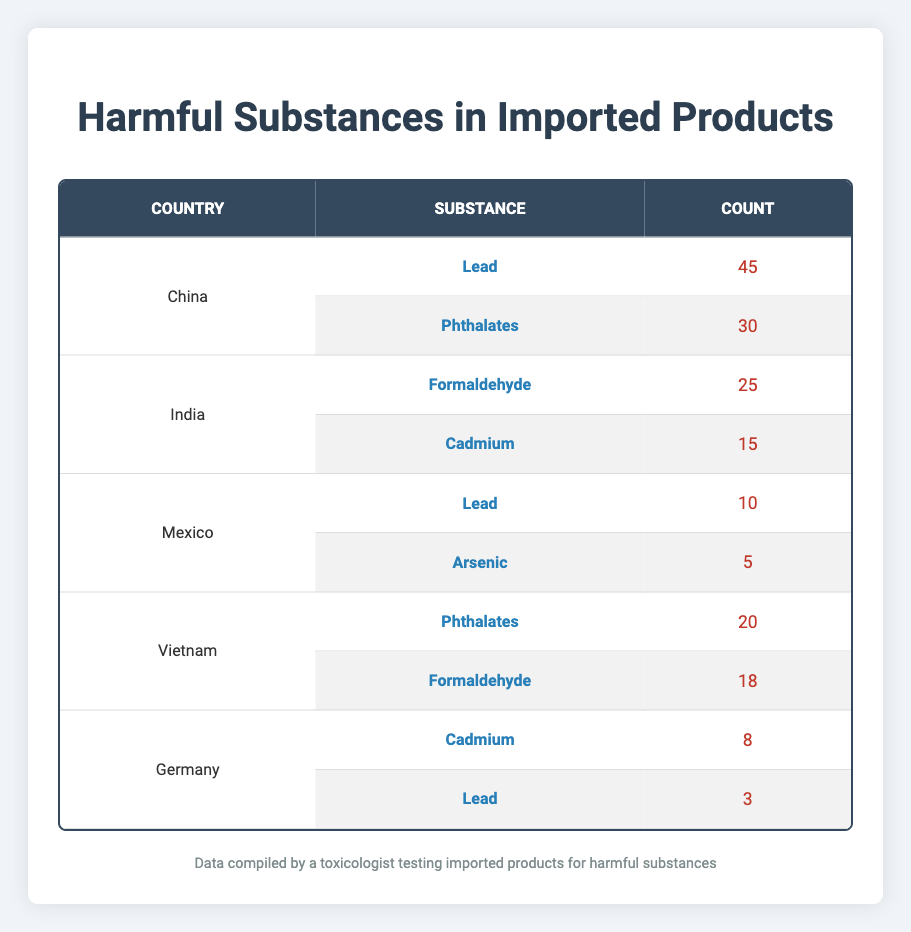What is the total count of harmful substances found in products imported from China? To find the total count of harmful substances from China, I sum the counts of all substances linked to China: Lead (45) + Phthalates (30) = 75.
Answer: 75 Which substance is found in the highest quantity in imported products from India? In India, the substances are Formaldehyde (25) and Cadmium (15). The highest count is for Formaldehyde, which has a count of 25.
Answer: Formaldehyde Is Lead detected in products from Mexico? Looking at the data for Mexico, I see that Lead is listed with a count of 10. Therefore, Lead is indeed detected in products imported from Mexico.
Answer: Yes What is the combined total count of Phthalates detected in products from Vietnam and China? Phthalates are detected in Vietnam (20) and China (30). Adding these counts gives me 20 + 30 = 50.
Answer: 50 Does Germany have a higher total count of harmful substances compared to Mexico? For Germany, the counts are Cadmium (8) and Lead (3), summing to 11. For Mexico, Lead (10) and Arsenic (5) sum to 15. Comparing these totals: Germany (11) is lower than Mexico (15).
Answer: No What is the average number of substances detected per country for which data is provided? There are 5 countries (China, India, Mexico, Vietnam, Germany) and a total of 8 substances detected. To find the average, I calculate 8 substances / 5 countries = 1.6.
Answer: 1.6 Which country has the smallest count for Cadmium? In the table, India has 15 as the count for Cadmium, Germany has a count of 8, and there is no count for Cadmium in any other country. Thus, Germany has the smallest count for Cadmium at 8.
Answer: Germany How many more counts of Formaldehyde are indicated in Vietnam than in India? The count of Formaldehyde in Vietnam is 18, while in India it is 25. To find the difference, I evaluate 18 - 25 = -7, which indicates that Vietnam has 7 fewer counts of Formaldehyde than India.
Answer: 7 fewer Do both China and Vietnam show detection of Phthalates? China has a count of 30 for Phthalates, and Vietnam has a count of 20. Therefore, both countries show detection of Phthalates.
Answer: Yes 